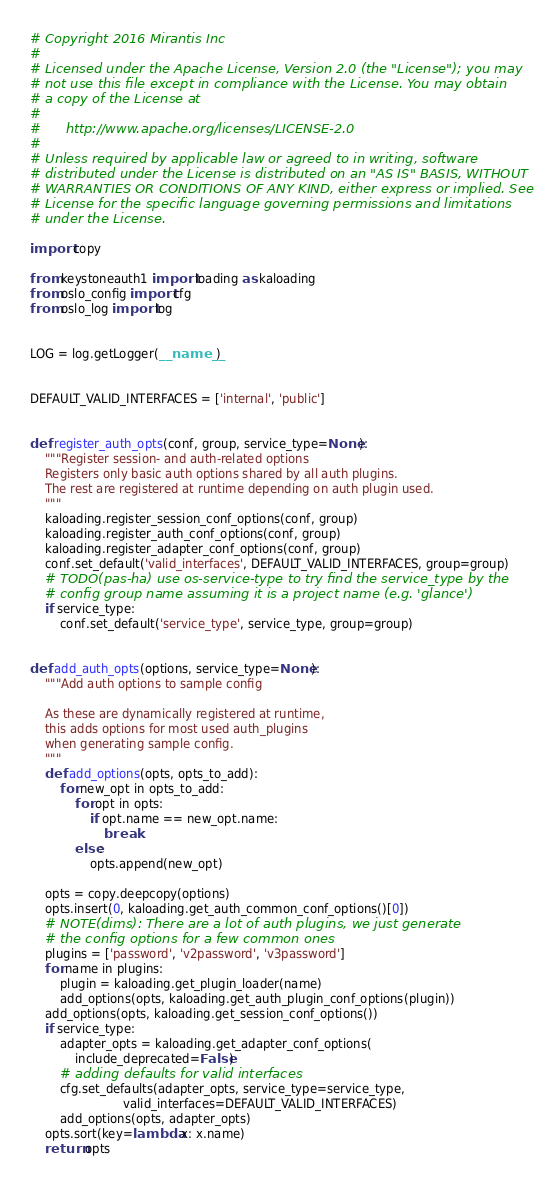<code> <loc_0><loc_0><loc_500><loc_500><_Python_># Copyright 2016 Mirantis Inc
#
# Licensed under the Apache License, Version 2.0 (the "License"); you may
# not use this file except in compliance with the License. You may obtain
# a copy of the License at
#
#      http://www.apache.org/licenses/LICENSE-2.0
#
# Unless required by applicable law or agreed to in writing, software
# distributed under the License is distributed on an "AS IS" BASIS, WITHOUT
# WARRANTIES OR CONDITIONS OF ANY KIND, either express or implied. See the
# License for the specific language governing permissions and limitations
# under the License.

import copy

from keystoneauth1 import loading as kaloading
from oslo_config import cfg
from oslo_log import log


LOG = log.getLogger(__name__)


DEFAULT_VALID_INTERFACES = ['internal', 'public']


def register_auth_opts(conf, group, service_type=None):
    """Register session- and auth-related options
    Registers only basic auth options shared by all auth plugins.
    The rest are registered at runtime depending on auth plugin used.
    """
    kaloading.register_session_conf_options(conf, group)
    kaloading.register_auth_conf_options(conf, group)
    kaloading.register_adapter_conf_options(conf, group)
    conf.set_default('valid_interfaces', DEFAULT_VALID_INTERFACES, group=group)
    # TODO(pas-ha) use os-service-type to try find the service_type by the
    # config group name assuming it is a project name (e.g. 'glance')
    if service_type:
        conf.set_default('service_type', service_type, group=group)


def add_auth_opts(options, service_type=None):
    """Add auth options to sample config

    As these are dynamically registered at runtime,
    this adds options for most used auth_plugins
    when generating sample config.
    """
    def add_options(opts, opts_to_add):
        for new_opt in opts_to_add:
            for opt in opts:
                if opt.name == new_opt.name:
                    break
            else:
                opts.append(new_opt)

    opts = copy.deepcopy(options)
    opts.insert(0, kaloading.get_auth_common_conf_options()[0])
    # NOTE(dims): There are a lot of auth plugins, we just generate
    # the config options for a few common ones
    plugins = ['password', 'v2password', 'v3password']
    for name in plugins:
        plugin = kaloading.get_plugin_loader(name)
        add_options(opts, kaloading.get_auth_plugin_conf_options(plugin))
    add_options(opts, kaloading.get_session_conf_options())
    if service_type:
        adapter_opts = kaloading.get_adapter_conf_options(
            include_deprecated=False)
        # adding defaults for valid interfaces
        cfg.set_defaults(adapter_opts, service_type=service_type,
                         valid_interfaces=DEFAULT_VALID_INTERFACES)
        add_options(opts, adapter_opts)
    opts.sort(key=lambda x: x.name)
    return opts
</code> 